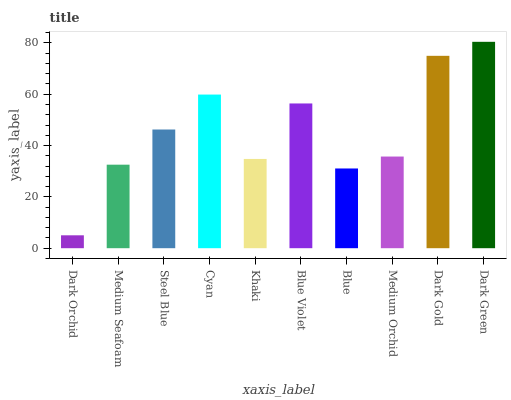Is Dark Orchid the minimum?
Answer yes or no. Yes. Is Dark Green the maximum?
Answer yes or no. Yes. Is Medium Seafoam the minimum?
Answer yes or no. No. Is Medium Seafoam the maximum?
Answer yes or no. No. Is Medium Seafoam greater than Dark Orchid?
Answer yes or no. Yes. Is Dark Orchid less than Medium Seafoam?
Answer yes or no. Yes. Is Dark Orchid greater than Medium Seafoam?
Answer yes or no. No. Is Medium Seafoam less than Dark Orchid?
Answer yes or no. No. Is Steel Blue the high median?
Answer yes or no. Yes. Is Medium Orchid the low median?
Answer yes or no. Yes. Is Blue Violet the high median?
Answer yes or no. No. Is Khaki the low median?
Answer yes or no. No. 